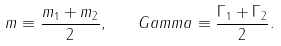<formula> <loc_0><loc_0><loc_500><loc_500>m \equiv \frac { m _ { 1 } + m _ { 2 } } { 2 } , \quad G a m m a \equiv \frac { \Gamma _ { 1 } + \Gamma _ { 2 } } { 2 } .</formula> 